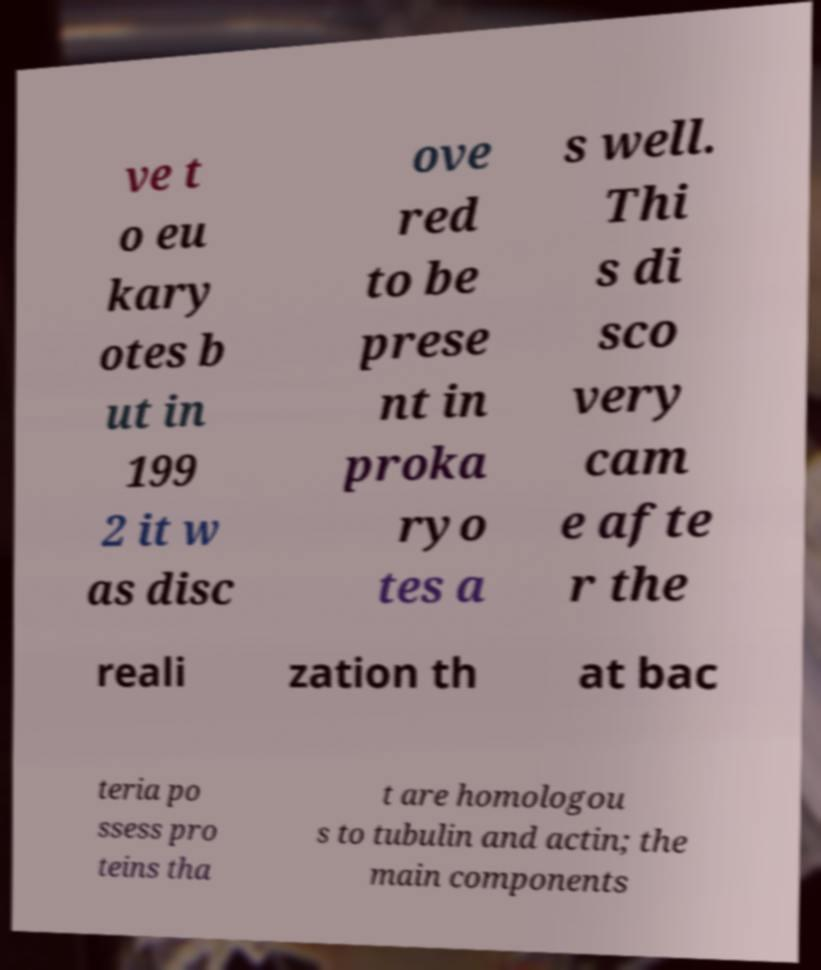Can you accurately transcribe the text from the provided image for me? ve t o eu kary otes b ut in 199 2 it w as disc ove red to be prese nt in proka ryo tes a s well. Thi s di sco very cam e afte r the reali zation th at bac teria po ssess pro teins tha t are homologou s to tubulin and actin; the main components 